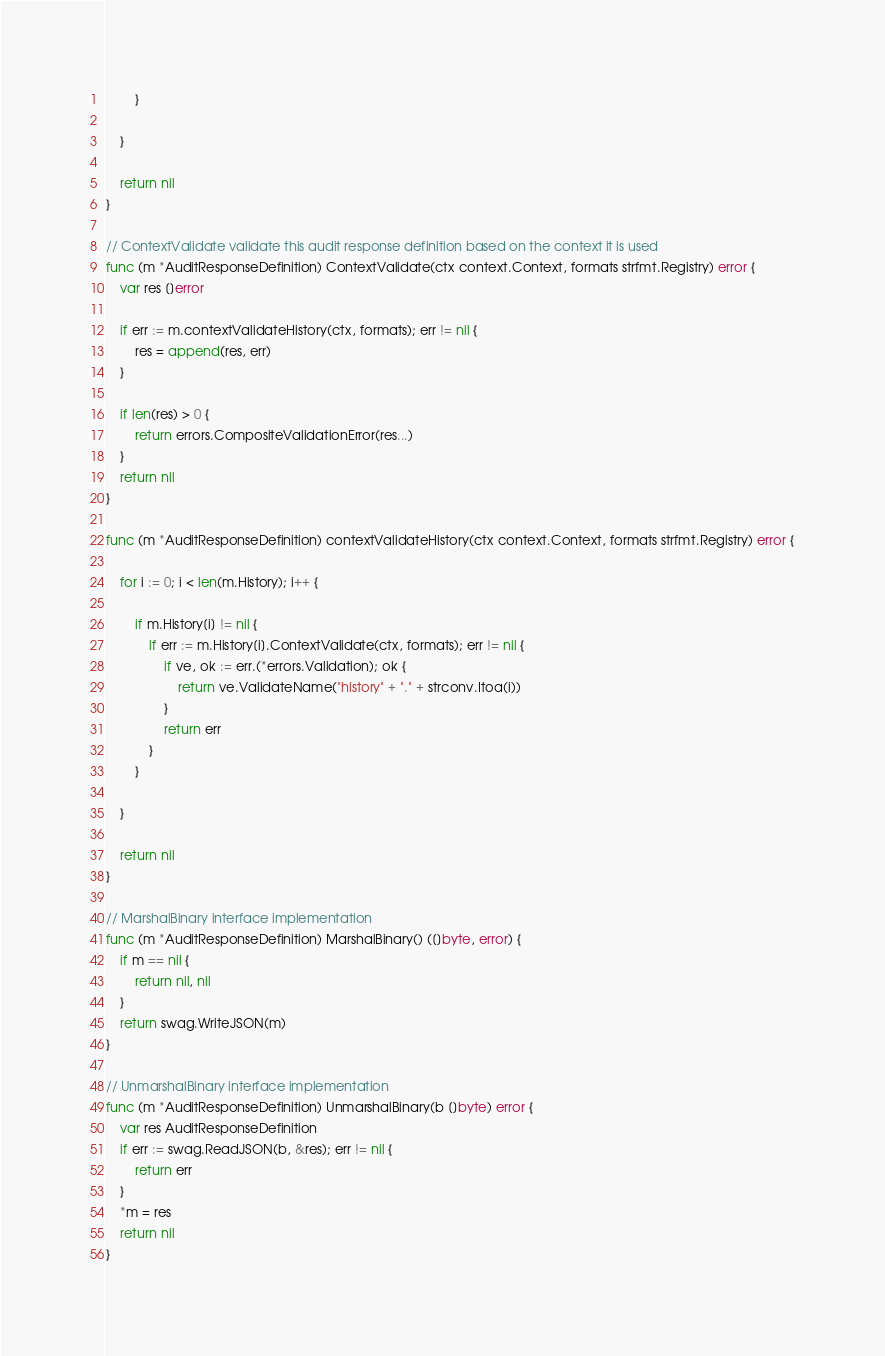Convert code to text. <code><loc_0><loc_0><loc_500><loc_500><_Go_>		}

	}

	return nil
}

// ContextValidate validate this audit response definition based on the context it is used
func (m *AuditResponseDefinition) ContextValidate(ctx context.Context, formats strfmt.Registry) error {
	var res []error

	if err := m.contextValidateHistory(ctx, formats); err != nil {
		res = append(res, err)
	}

	if len(res) > 0 {
		return errors.CompositeValidationError(res...)
	}
	return nil
}

func (m *AuditResponseDefinition) contextValidateHistory(ctx context.Context, formats strfmt.Registry) error {

	for i := 0; i < len(m.History); i++ {

		if m.History[i] != nil {
			if err := m.History[i].ContextValidate(ctx, formats); err != nil {
				if ve, ok := err.(*errors.Validation); ok {
					return ve.ValidateName("history" + "." + strconv.Itoa(i))
				}
				return err
			}
		}

	}

	return nil
}

// MarshalBinary interface implementation
func (m *AuditResponseDefinition) MarshalBinary() ([]byte, error) {
	if m == nil {
		return nil, nil
	}
	return swag.WriteJSON(m)
}

// UnmarshalBinary interface implementation
func (m *AuditResponseDefinition) UnmarshalBinary(b []byte) error {
	var res AuditResponseDefinition
	if err := swag.ReadJSON(b, &res); err != nil {
		return err
	}
	*m = res
	return nil
}
</code> 